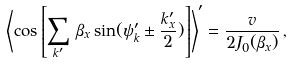<formula> <loc_0><loc_0><loc_500><loc_500>\left < \cos \left [ \sum _ { k ^ { \prime } } \, \beta _ { x } \sin ( \psi ^ { \prime } _ { k } \pm \frac { k ^ { \prime } _ { x } } { 2 } ) \right ] \right > ^ { \prime } = \frac { v } { 2 J _ { 0 } ( \beta _ { x } ) } \, ,</formula> 